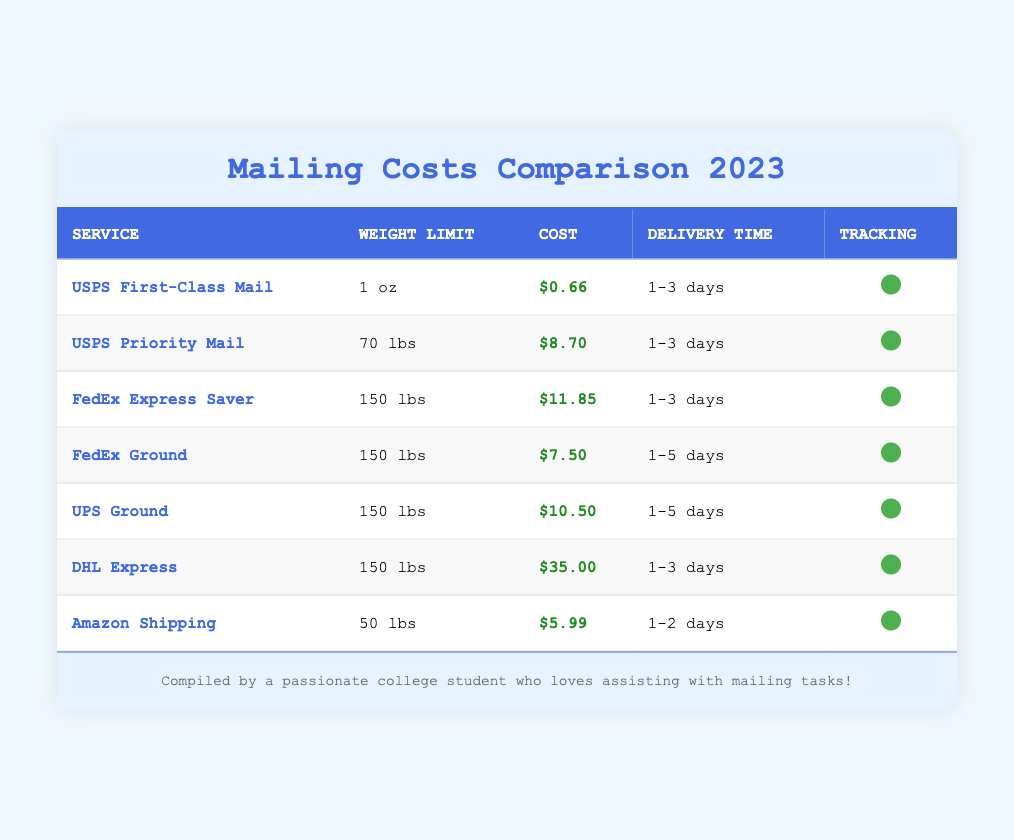What is the cost of USPS First-Class Mail? The cost is listed directly in the table next to the service name USPS First-Class Mail. It shows $0.66 as the cost.
Answer: $0.66 What is the delivery time for FedEx Express Saver? The delivery time is mentioned in the column for delivery time next to FedEx Express Saver, which indicates 1-3 days.
Answer: 1-3 days Which service has the highest cost? By comparing the costs of all listed services, DHL Express shows the highest cost at $35.00.
Answer: $35.00 Is tracking available with UPS Ground? The table indicates whether tracking is available by checking the corresponding column for UPS Ground, which does show that tracking is available (true).
Answer: Yes What is the average cost of mailing for services that deliver within 1-3 days? The services that deliver within 1-3 days are USPS First-Class Mail ($0.66), USPS Priority Mail ($8.70), FedEx Express Saver ($11.85), and DHL Express ($35.00). Adding these costs gives 0.66 + 8.70 + 11.85 + 35.00 = 56.21. The average is calculated by dividing this sum by the number of services, which is 4. Therefore, the average cost is 56.21 / 4 = 14.05.
Answer: $14.05 What is the weight limit for Amazon Shipping? The weight limit is presented in the weight limit column next to the Amazon Shipping service, which shows a limit of 50 lbs.
Answer: 50 lbs 